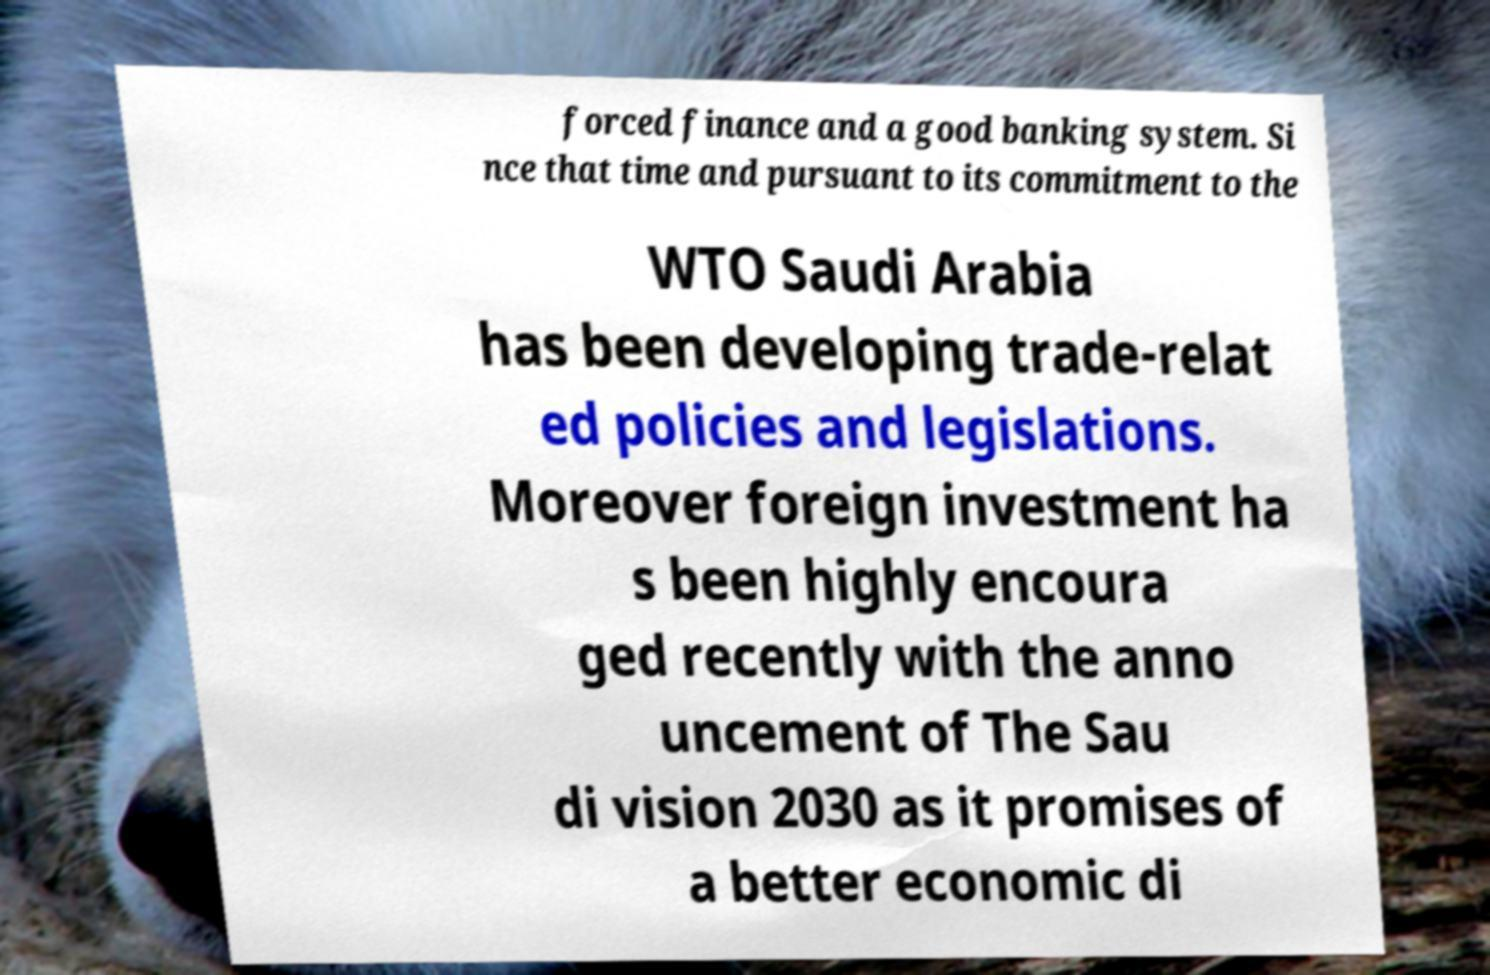Could you assist in decoding the text presented in this image and type it out clearly? forced finance and a good banking system. Si nce that time and pursuant to its commitment to the WTO Saudi Arabia has been developing trade-relat ed policies and legislations. Moreover foreign investment ha s been highly encoura ged recently with the anno uncement of The Sau di vision 2030 as it promises of a better economic di 